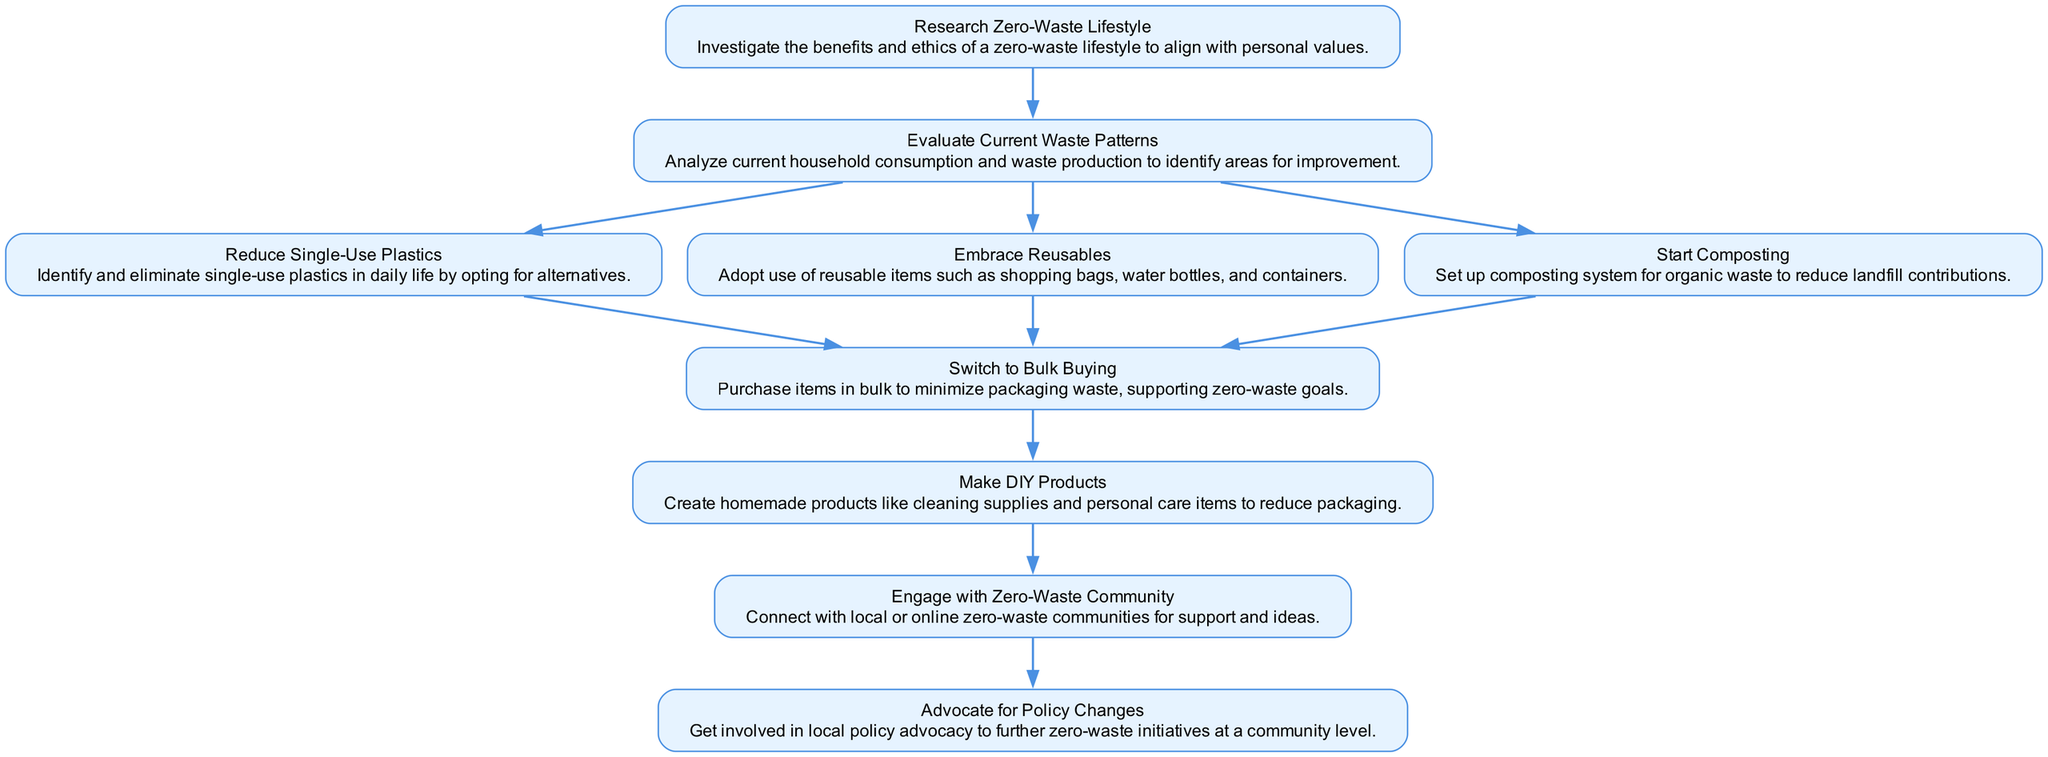What is the first activity in the diagram? The first activity listed in the diagram is "Research Zero-Waste Lifestyle." It is the starting point of the flow and does not have any preceding activities.
Answer: Research Zero-Waste Lifestyle How many activities are in the diagram? To find the number of activities, I counted each unique node in the diagram, which includes all the activities listed. There are ten distinct activities present.
Answer: 10 What is the last activity in the flow? The last activity is "Advocate for Policy Changes," which has no subsequent activities leading from it in the diagram. It represents the final step in the transition process.
Answer: Advocate for Policy Changes Which activity comes after "Embrace Reusables"? Following "Embrace Reusables," the next activity is "Switch to Bulk Buying." This is determined by looking at the connections from "Embrace Reusables" in the diagram.
Answer: Switch to Bulk Buying How many edges connect to "Switch to Bulk Buying"? There are three edges connecting to "Switch to Bulk Buying," as it receives connections from three different preceding activities: "Reduce Single-Use Plastics," "Embrace Reusables," and "Start Composting."
Answer: 3 What activities lead into "Make DIY Products"? The activity "Make DIY Products" is preceded by only one activity, which is "Switch to Bulk Buying." This indicates that "Switch to Bulk Buying" needs to be completed before progressing to "Make DIY Products."
Answer: Switch to Bulk Buying Which two activities lead to the "Engage with Zero-Waste Community" activity? The activities that lead to "Engage with Zero-Waste Community" are "Make DIY Products." There are no other activities directly connecting to it in the flow.
Answer: Make DIY Products How does one transition from researching to evaluating waste patterns? The transition from "Research Zero-Waste Lifestyle" to "Evaluate Current Waste Patterns" is direct, as "Evaluate Current Waste Patterns" is the next step following the research stage in the flow.
Answer: Evaluate Current Waste Patterns Which activity does not lead to any next steps? The activity "Advocate for Policy Changes" does not lead to any next steps because it is the final activity in the diagram with no following connections.
Answer: Advocate for Policy Changes 